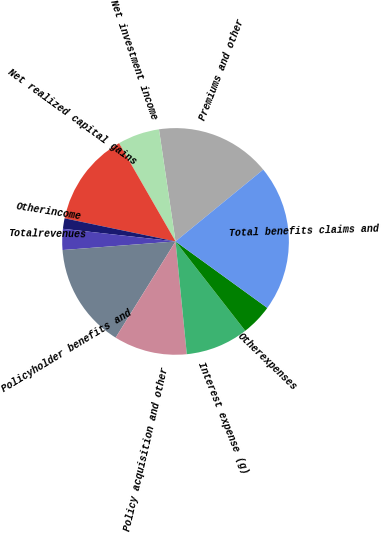Convert chart to OTSL. <chart><loc_0><loc_0><loc_500><loc_500><pie_chart><fcel>Premiums and other<fcel>Net investment income<fcel>Net realized capital gains<fcel>Otherincome<fcel>Totalrevenues<fcel>Policyholder benefits and<fcel>Policy acquisition and other<fcel>Interest expense (g)<fcel>Otherexpenses<fcel>Total benefits claims and<nl><fcel>16.42%<fcel>5.97%<fcel>13.43%<fcel>1.49%<fcel>2.99%<fcel>14.93%<fcel>10.45%<fcel>8.96%<fcel>4.48%<fcel>20.9%<nl></chart> 